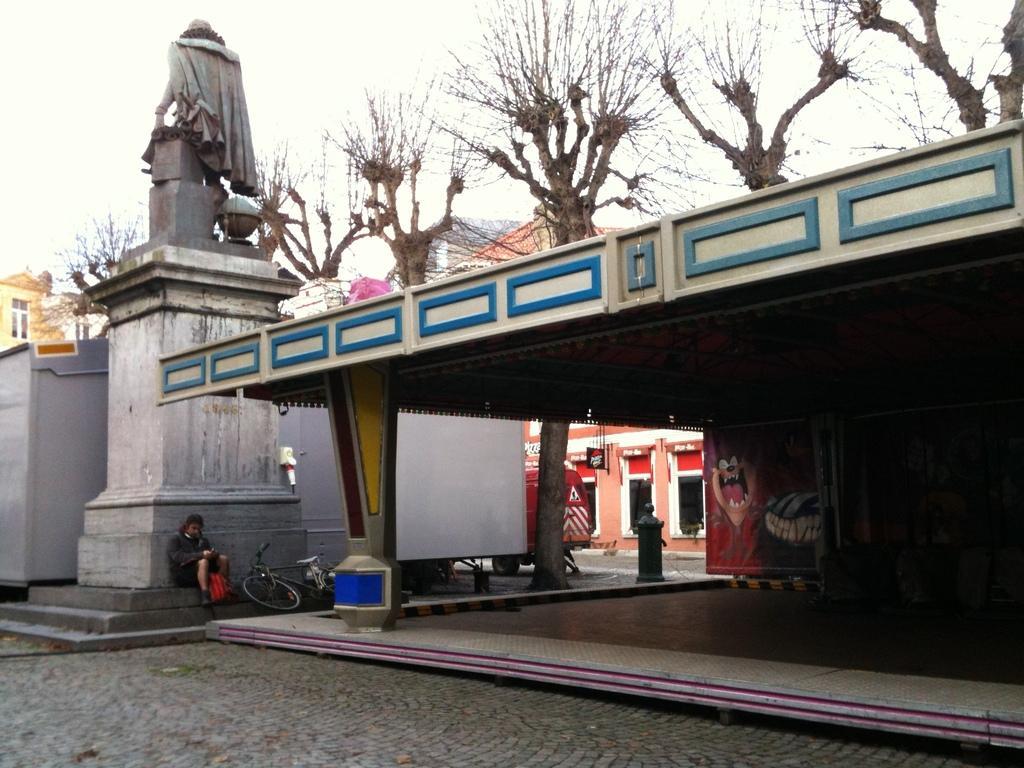Can you describe this image briefly? In this image we can see a statue. In front of it one girl is sitting on the stair. Be side her bicycle is present. Right side of the image shelter like structure is present. Background of the image trees and buildings are present. 